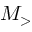<formula> <loc_0><loc_0><loc_500><loc_500>M _ { > }</formula> 